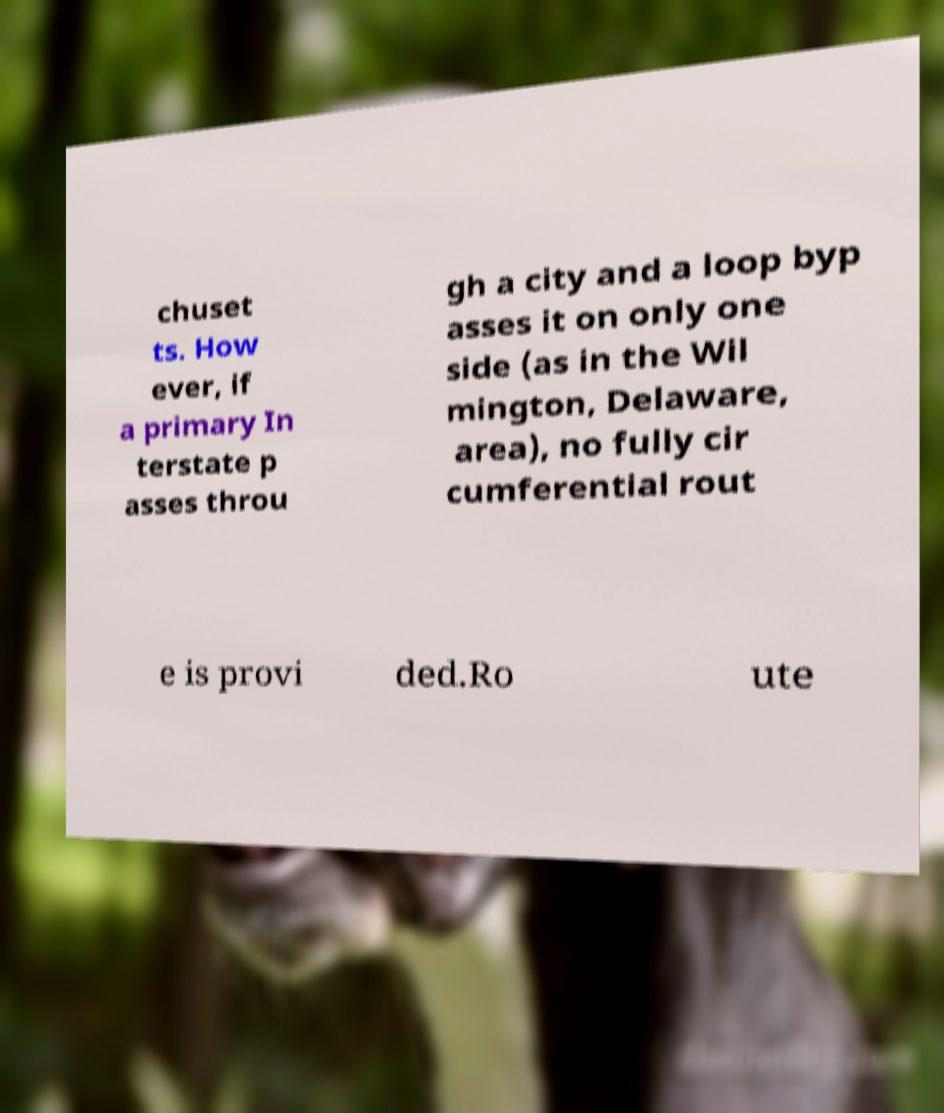Can you read and provide the text displayed in the image?This photo seems to have some interesting text. Can you extract and type it out for me? chuset ts. How ever, if a primary In terstate p asses throu gh a city and a loop byp asses it on only one side (as in the Wil mington, Delaware, area), no fully cir cumferential rout e is provi ded.Ro ute 